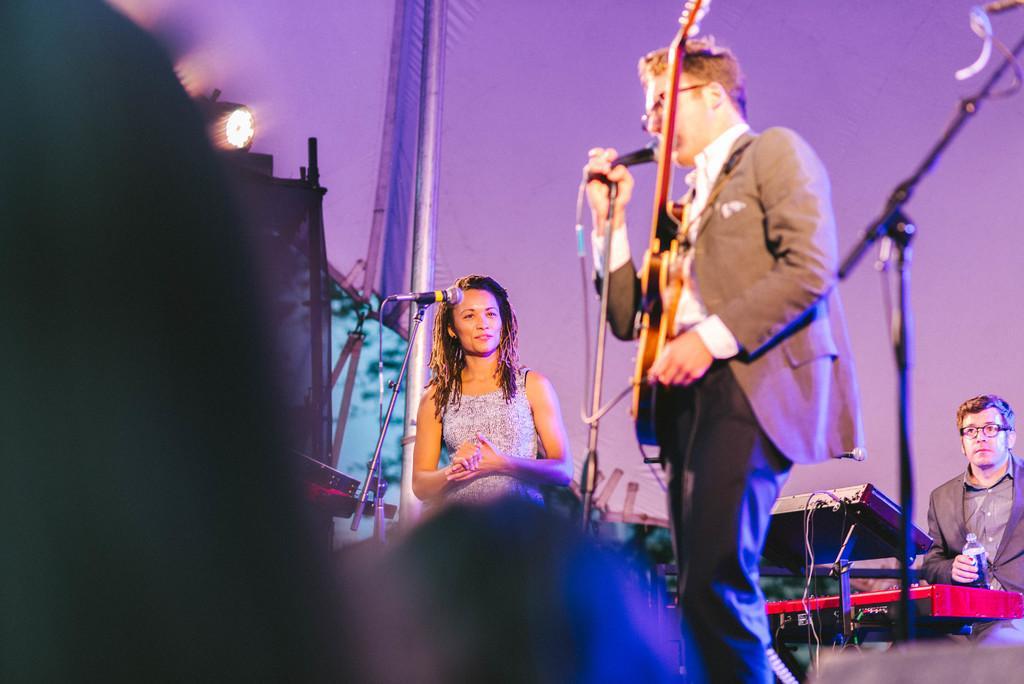In one or two sentences, can you explain what this image depicts? In this picture we can see man standing carrying guitar and singing on mic beside to her woman smiling and here man sitting holding bottle in his hand and in background we can see wall, light. 